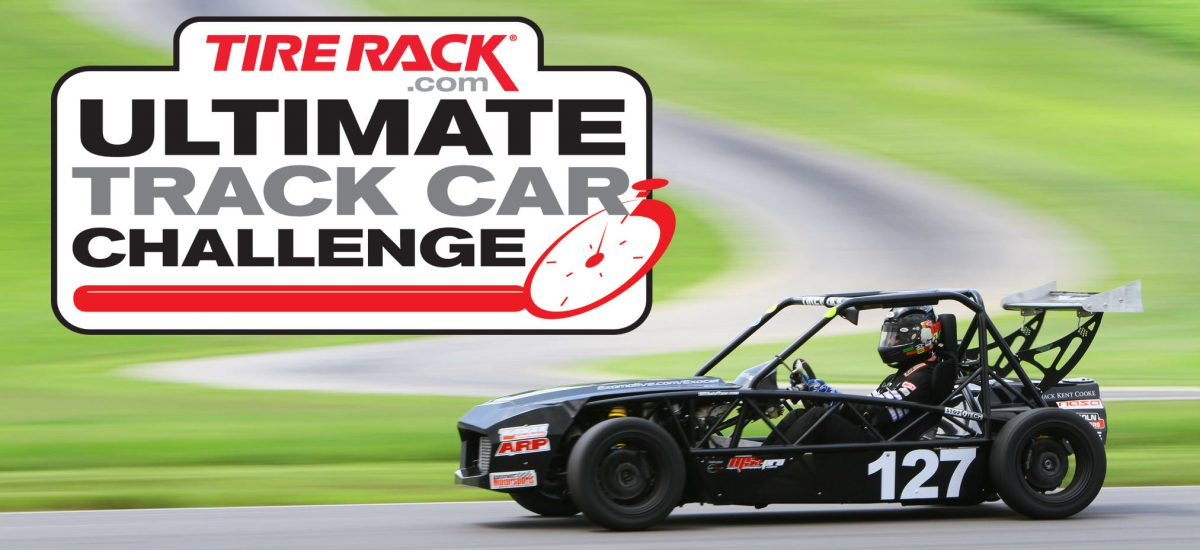Given the design and construction of the car, what specific race categories or events could this vehicle be eligible to compete in, and what characteristics of the car support this assessment? The car in the image, with its competition number clearly visible, is designed to excel in high-performance racing events like autocross, time attack, or hill climb races, where precision and handling are paramount over raw speed alone. Its open-wheel configuration, extensive use of aerodynamic components such as the large rear wing and front splitter, along with a stripped-out chassis to minimize weight, all pinpoint refinement for a tight handling envelope. The slick tires are indicative of a vehicle that runs in dry conditions where maximum grip is essential. This vehicle is likely to be classified under sports racer or prototype classes in events organized by bodies such as the SCCA (Sports Car Club of America) or similar motorsport organizations that focus on amateur and semi-professional circuit racing. 